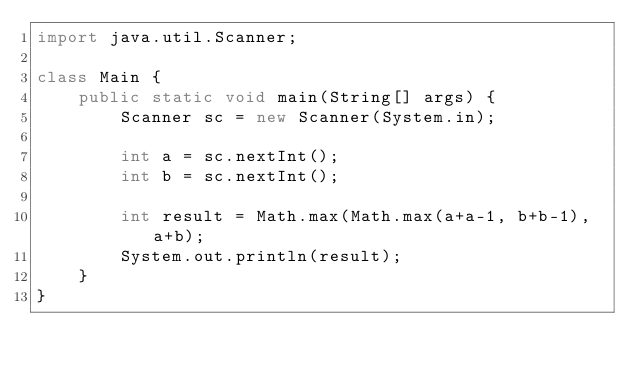<code> <loc_0><loc_0><loc_500><loc_500><_Java_>import java.util.Scanner;

class Main {
    public static void main(String[] args) {
        Scanner sc = new Scanner(System.in);
      
        int a = sc.nextInt();
        int b = sc.nextInt();
      
        int result = Math.max(Math.max(a+a-1, b+b-1), a+b);
        System.out.println(result);
    }
}
</code> 